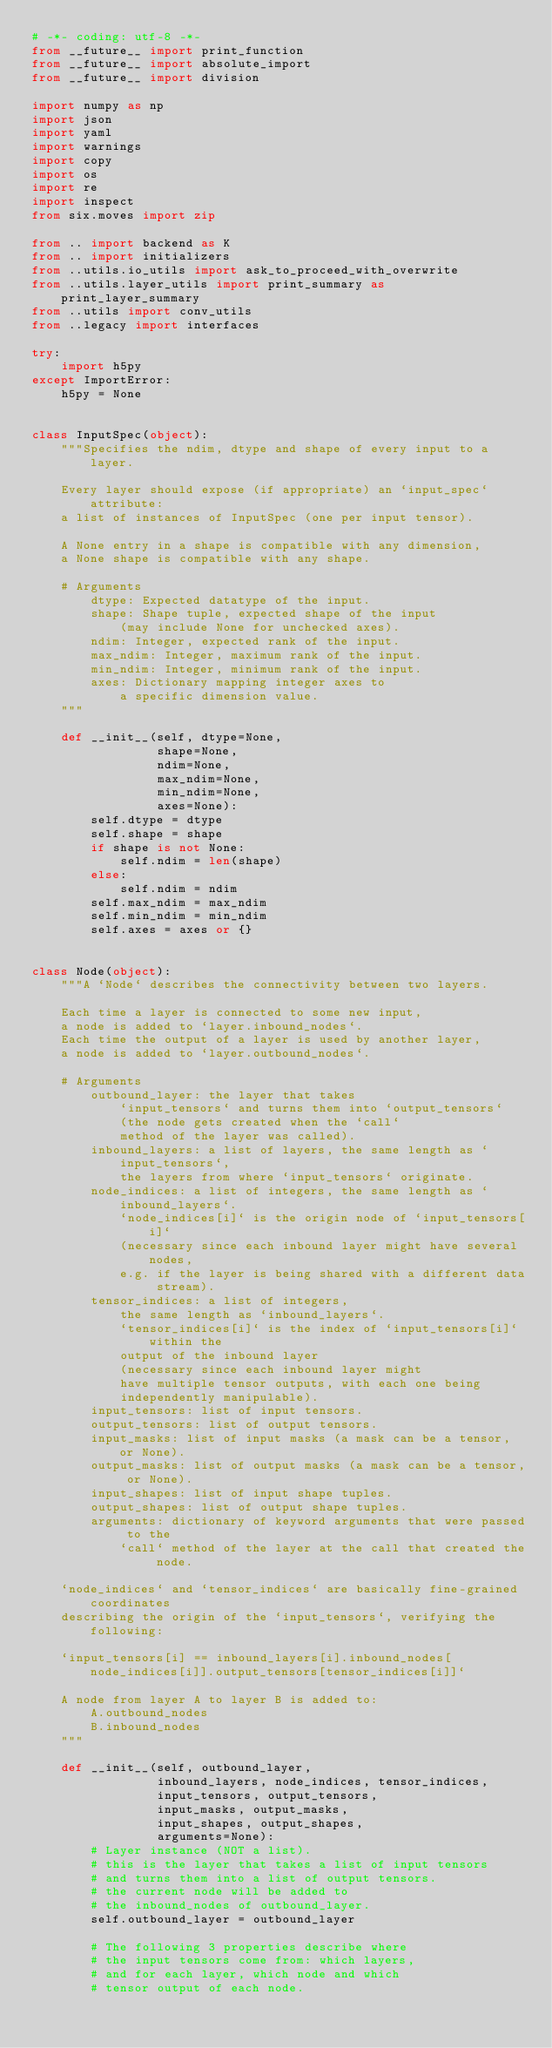<code> <loc_0><loc_0><loc_500><loc_500><_Python_># -*- coding: utf-8 -*-
from __future__ import print_function
from __future__ import absolute_import
from __future__ import division

import numpy as np
import json
import yaml
import warnings
import copy
import os
import re
import inspect
from six.moves import zip

from .. import backend as K
from .. import initializers
from ..utils.io_utils import ask_to_proceed_with_overwrite
from ..utils.layer_utils import print_summary as print_layer_summary
from ..utils import conv_utils
from ..legacy import interfaces

try:
    import h5py
except ImportError:
    h5py = None


class InputSpec(object):
    """Specifies the ndim, dtype and shape of every input to a layer.

    Every layer should expose (if appropriate) an `input_spec` attribute:
    a list of instances of InputSpec (one per input tensor).

    A None entry in a shape is compatible with any dimension,
    a None shape is compatible with any shape.

    # Arguments
        dtype: Expected datatype of the input.
        shape: Shape tuple, expected shape of the input
            (may include None for unchecked axes).
        ndim: Integer, expected rank of the input.
        max_ndim: Integer, maximum rank of the input.
        min_ndim: Integer, minimum rank of the input.
        axes: Dictionary mapping integer axes to
            a specific dimension value.
    """

    def __init__(self, dtype=None,
                 shape=None,
                 ndim=None,
                 max_ndim=None,
                 min_ndim=None,
                 axes=None):
        self.dtype = dtype
        self.shape = shape
        if shape is not None:
            self.ndim = len(shape)
        else:
            self.ndim = ndim
        self.max_ndim = max_ndim
        self.min_ndim = min_ndim
        self.axes = axes or {}


class Node(object):
    """A `Node` describes the connectivity between two layers.

    Each time a layer is connected to some new input,
    a node is added to `layer.inbound_nodes`.
    Each time the output of a layer is used by another layer,
    a node is added to `layer.outbound_nodes`.

    # Arguments
        outbound_layer: the layer that takes
            `input_tensors` and turns them into `output_tensors`
            (the node gets created when the `call`
            method of the layer was called).
        inbound_layers: a list of layers, the same length as `input_tensors`,
            the layers from where `input_tensors` originate.
        node_indices: a list of integers, the same length as `inbound_layers`.
            `node_indices[i]` is the origin node of `input_tensors[i]`
            (necessary since each inbound layer might have several nodes,
            e.g. if the layer is being shared with a different data stream).
        tensor_indices: a list of integers,
            the same length as `inbound_layers`.
            `tensor_indices[i]` is the index of `input_tensors[i]` within the
            output of the inbound layer
            (necessary since each inbound layer might
            have multiple tensor outputs, with each one being
            independently manipulable).
        input_tensors: list of input tensors.
        output_tensors: list of output tensors.
        input_masks: list of input masks (a mask can be a tensor, or None).
        output_masks: list of output masks (a mask can be a tensor, or None).
        input_shapes: list of input shape tuples.
        output_shapes: list of output shape tuples.
        arguments: dictionary of keyword arguments that were passed to the
            `call` method of the layer at the call that created the node.

    `node_indices` and `tensor_indices` are basically fine-grained coordinates
    describing the origin of the `input_tensors`, verifying the following:

    `input_tensors[i] == inbound_layers[i].inbound_nodes[node_indices[i]].output_tensors[tensor_indices[i]]`

    A node from layer A to layer B is added to:
        A.outbound_nodes
        B.inbound_nodes
    """

    def __init__(self, outbound_layer,
                 inbound_layers, node_indices, tensor_indices,
                 input_tensors, output_tensors,
                 input_masks, output_masks,
                 input_shapes, output_shapes,
                 arguments=None):
        # Layer instance (NOT a list).
        # this is the layer that takes a list of input tensors
        # and turns them into a list of output tensors.
        # the current node will be added to
        # the inbound_nodes of outbound_layer.
        self.outbound_layer = outbound_layer

        # The following 3 properties describe where
        # the input tensors come from: which layers,
        # and for each layer, which node and which
        # tensor output of each node.
</code> 